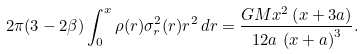<formula> <loc_0><loc_0><loc_500><loc_500>2 \pi ( 3 - 2 \beta ) \int _ { 0 } ^ { x } \rho ( r ) \sigma _ { r } ^ { 2 } ( r ) r ^ { 2 } \, d r = { \frac { G M { x } ^ { 2 } \left ( x + 3 a \right ) } { 1 2 a \, \left ( x + a \right ) ^ { 3 } } } .</formula> 